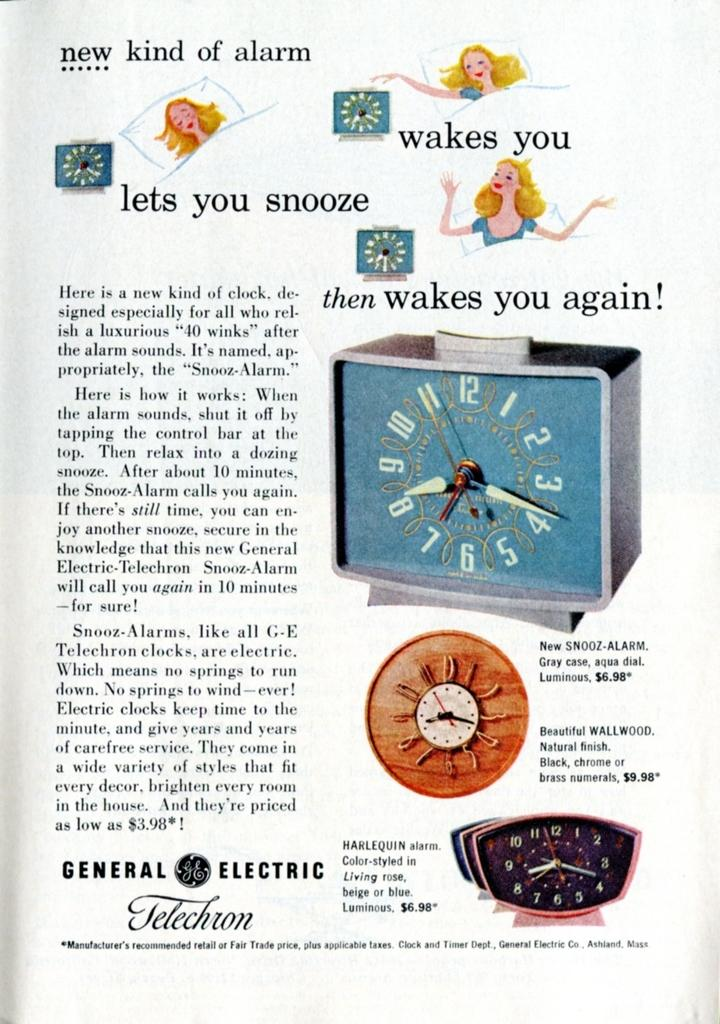<image>
Describe the image concisely. Poster that starts off by saying "New kind of alarm". 